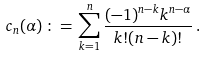Convert formula to latex. <formula><loc_0><loc_0><loc_500><loc_500>c _ { n } ( \alpha ) \, \colon = \, \sum _ { k = 1 } ^ { n } \frac { ( - 1 ) ^ { n - k } k ^ { n - \alpha } } { k ! ( n - k ) ! } \, .</formula> 